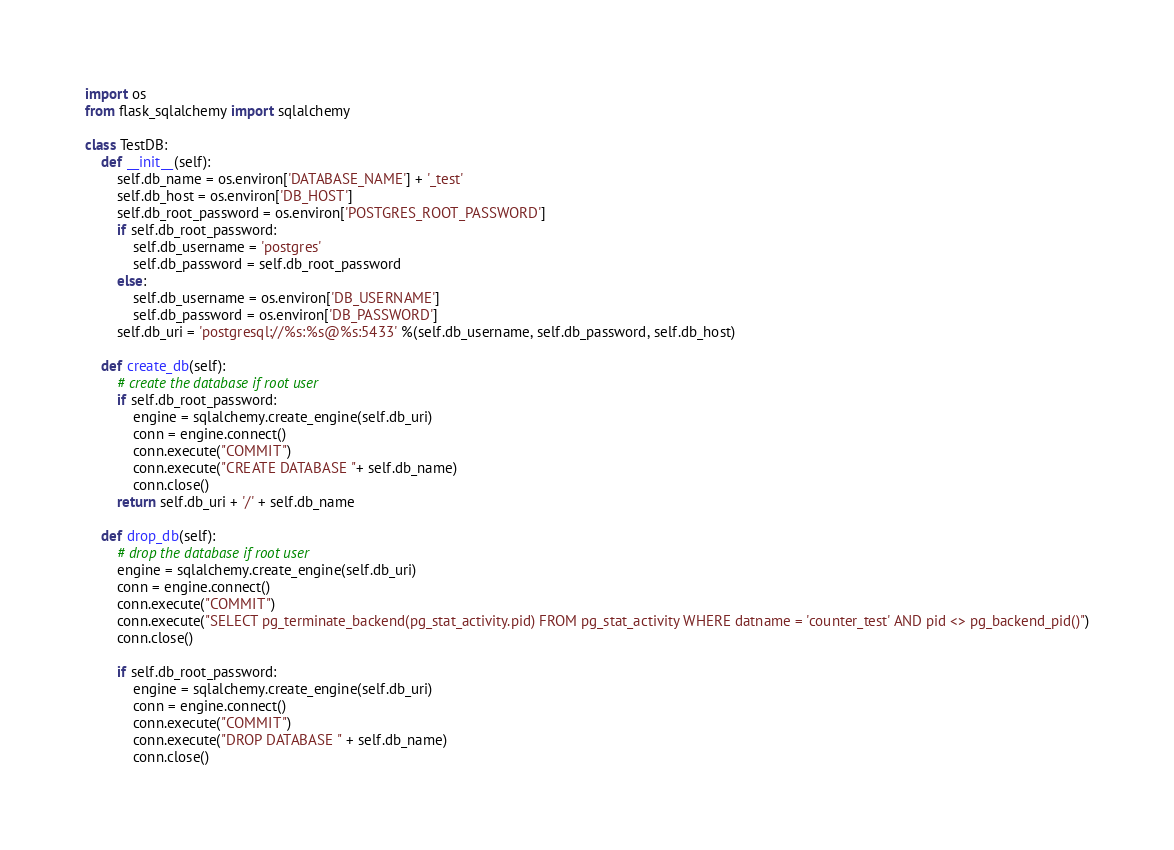Convert code to text. <code><loc_0><loc_0><loc_500><loc_500><_Python_>import os
from flask_sqlalchemy import sqlalchemy

class TestDB:
    def __init__(self):
        self.db_name = os.environ['DATABASE_NAME'] + '_test'
        self.db_host = os.environ['DB_HOST']
        self.db_root_password = os.environ['POSTGRES_ROOT_PASSWORD']
        if self.db_root_password:
            self.db_username = 'postgres'
            self.db_password = self.db_root_password
        else:
            self.db_username = os.environ['DB_USERNAME']
            self.db_password = os.environ['DB_PASSWORD']
        self.db_uri = 'postgresql://%s:%s@%s:5433' %(self.db_username, self.db_password, self.db_host)

    def create_db(self):
        # create the database if root user
        if self.db_root_password:
            engine = sqlalchemy.create_engine(self.db_uri)
            conn = engine.connect()
            conn.execute("COMMIT")
            conn.execute("CREATE DATABASE "+ self.db_name)
            conn.close()
        return self.db_uri + '/' + self.db_name

    def drop_db(self):
        # drop the database if root user
        engine = sqlalchemy.create_engine(self.db_uri)
        conn = engine.connect()
        conn.execute("COMMIT")
        conn.execute("SELECT pg_terminate_backend(pg_stat_activity.pid) FROM pg_stat_activity WHERE datname = 'counter_test' AND pid <> pg_backend_pid()")
        conn.close()

        if self.db_root_password:
            engine = sqlalchemy.create_engine(self.db_uri)
            conn = engine.connect()
            conn.execute("COMMIT")
            conn.execute("DROP DATABASE " + self.db_name)
            conn.close()
</code> 